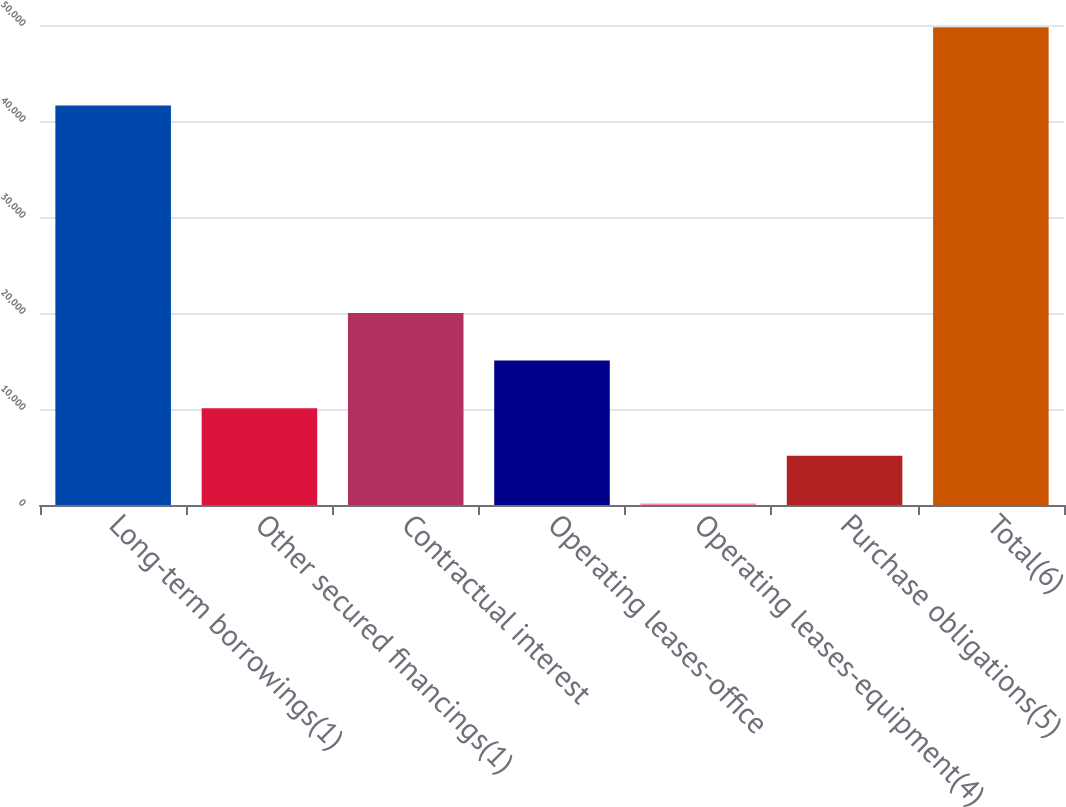<chart> <loc_0><loc_0><loc_500><loc_500><bar_chart><fcel>Long-term borrowings(1)<fcel>Other secured financings(1)<fcel>Contractual interest<fcel>Operating leases-office<fcel>Operating leases-equipment(4)<fcel>Purchase obligations(5)<fcel>Total(6)<nl><fcel>41603<fcel>10081.6<fcel>20000.2<fcel>15040.9<fcel>163<fcel>5122.3<fcel>49756<nl></chart> 